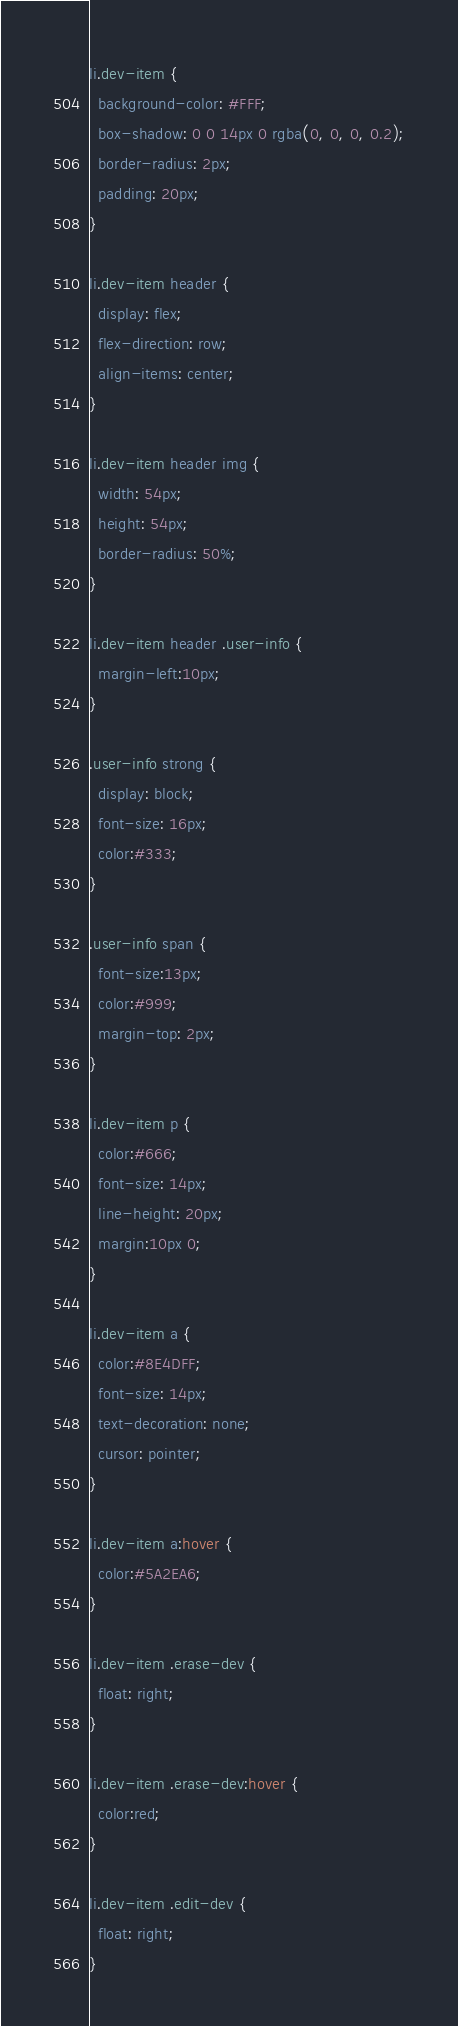Convert code to text. <code><loc_0><loc_0><loc_500><loc_500><_CSS_>li.dev-item {
  background-color: #FFF;
  box-shadow: 0 0 14px 0 rgba(0, 0, 0, 0.2);
  border-radius: 2px;
  padding: 20px;
}

li.dev-item header {
  display: flex;
  flex-direction: row;
  align-items: center;
}

li.dev-item header img {
  width: 54px;
  height: 54px;
  border-radius: 50%;
} 

li.dev-item header .user-info {
  margin-left:10px;
}

.user-info strong {
  display: block;
  font-size: 16px;
  color:#333;
}

.user-info span {
  font-size:13px;
  color:#999;
  margin-top: 2px;
}

li.dev-item p {
  color:#666;
  font-size: 14px;
  line-height: 20px;
  margin:10px 0;
}

li.dev-item a {
  color:#8E4DFF;
  font-size: 14px;
  text-decoration: none;
  cursor: pointer;
}

li.dev-item a:hover {
  color:#5A2EA6;
}

li.dev-item .erase-dev {
  float: right;
}

li.dev-item .erase-dev:hover {
  color:red;
}

li.dev-item .edit-dev {
  float: right;
}</code> 